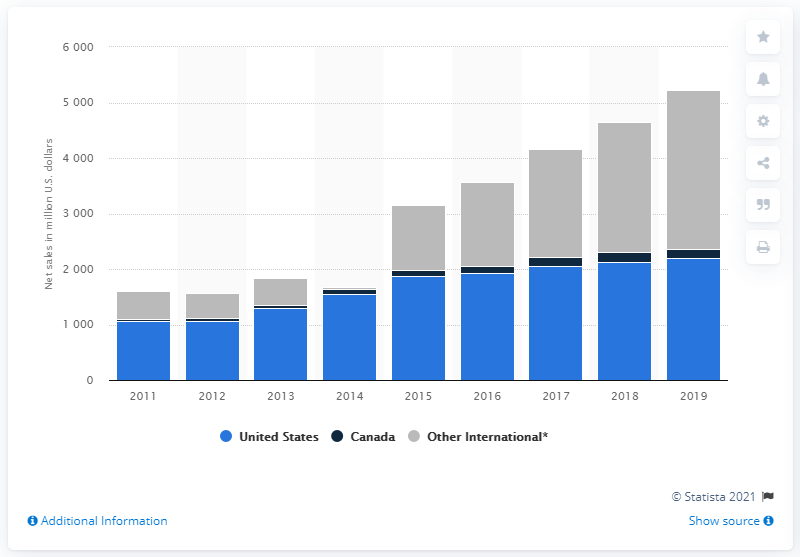List a handful of essential elements in this visual. In 2019, the net sales of Skechers in the United States were approximately 2197.39 million dollars. 